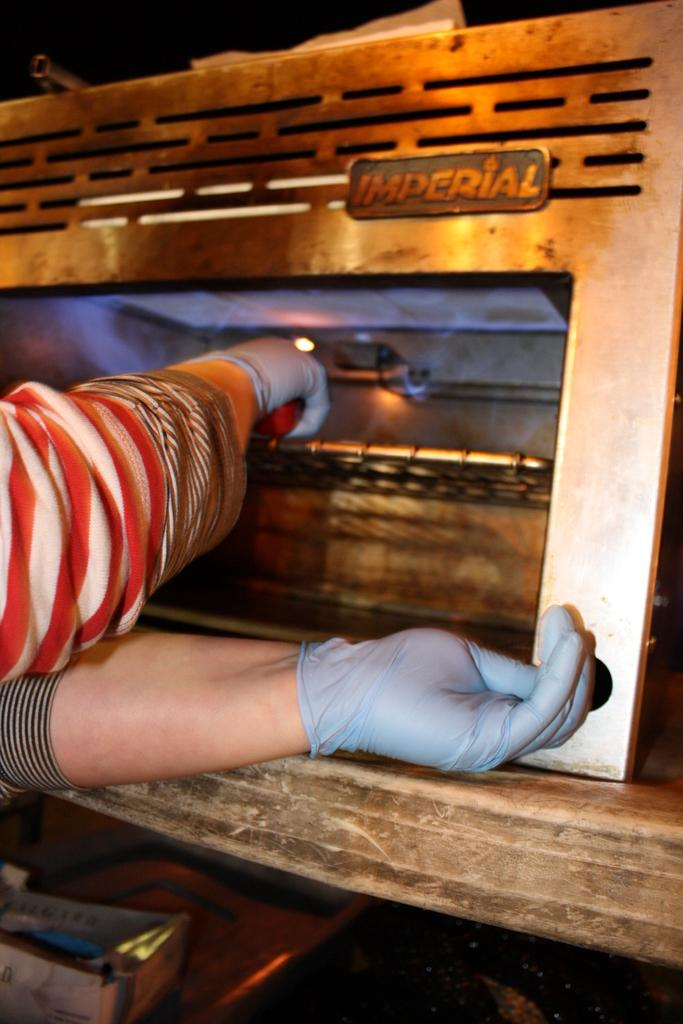What part of the human body is visible in the image? There is a human hand in the image. What type of appliance can be seen in the image? There is an oven in the image. Can you tell me how many robins are sitting on the oven in the image? There are no robins present in the image; it only features a human hand and an oven. Is there a bomb visible in the image? There is no bomb present in the image. 